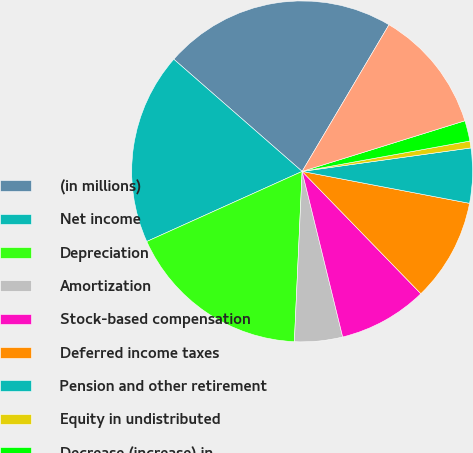Convert chart to OTSL. <chart><loc_0><loc_0><loc_500><loc_500><pie_chart><fcel>(in millions)<fcel>Net income<fcel>Depreciation<fcel>Amortization<fcel>Stock-based compensation<fcel>Deferred income taxes<fcel>Pension and other retirement<fcel>Equity in undistributed<fcel>Decrease (increase) in<fcel>Increase in inventories<nl><fcel>22.08%<fcel>18.18%<fcel>17.53%<fcel>4.55%<fcel>8.44%<fcel>9.74%<fcel>5.2%<fcel>0.65%<fcel>1.95%<fcel>11.69%<nl></chart> 